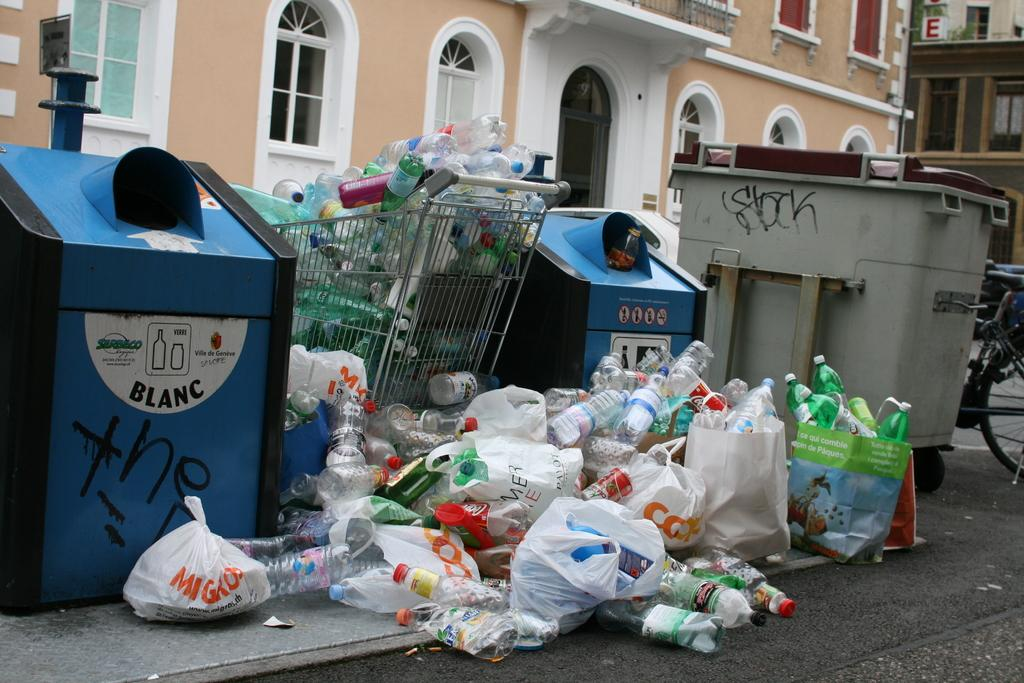Provide a one-sentence caption for the provided image. A huge amount of plastic bottles are stacked against recycle bins one of which read Blacn in a French street. 